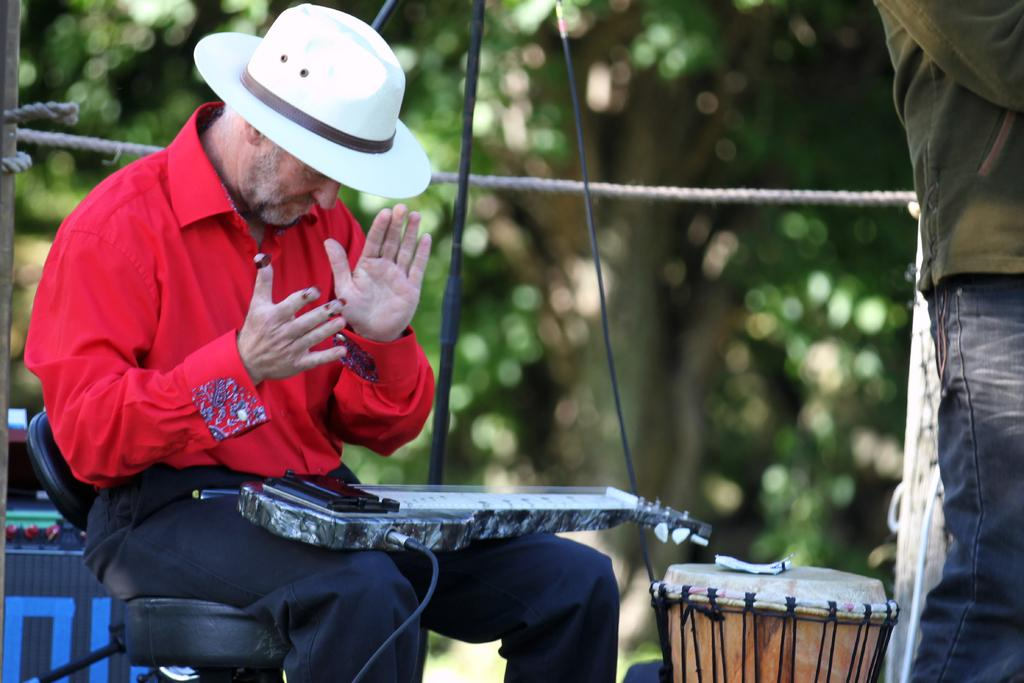What is the man in the image doing? The man is sitting on a chair in the image. What else can be seen with the man in the image? The man has some musical instruments on him. What can be seen in the background of the image? There is a tree visible in the background of the image. What type of treatment is the man receiving in the park? There is no park present in the image, and the man is not receiving any treatment. 